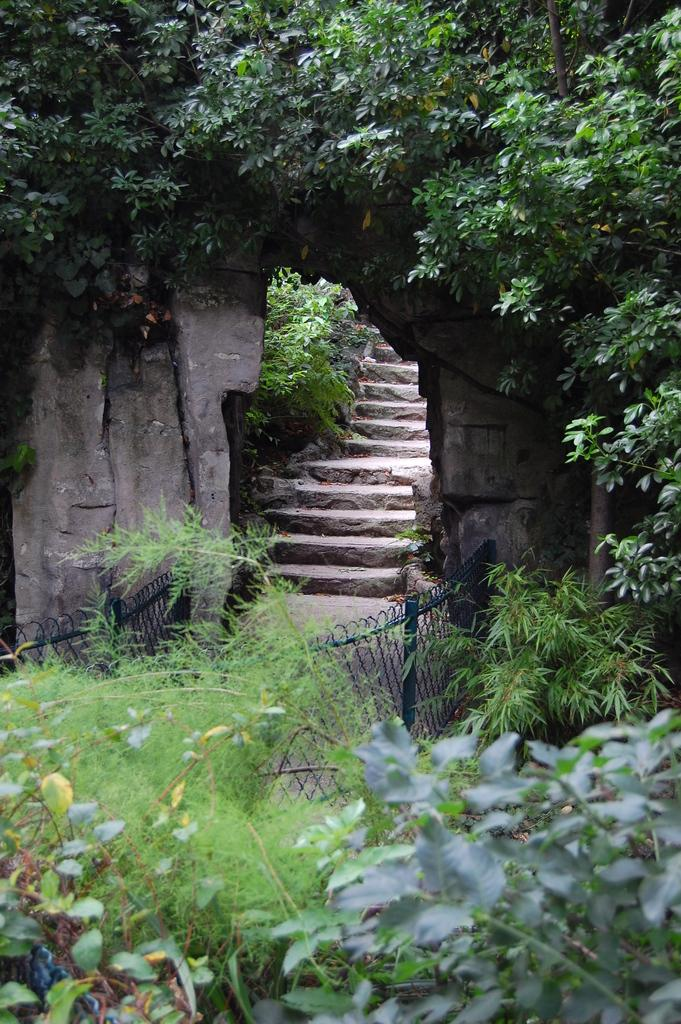What type of living organisms can be seen in the image? Plants can be seen in the image. What is located in the front of the image? There is fencing in the front of the image. What can be seen in the background of the image? Trees and stairs can be seen in the background of the image. What type of liquid can be seen flowing from the plants in the image? There is no liquid flowing from the plants in the image. Can you describe the facial expressions of the birds in the image? There are no birds present in the image, so their facial expressions cannot be described. 